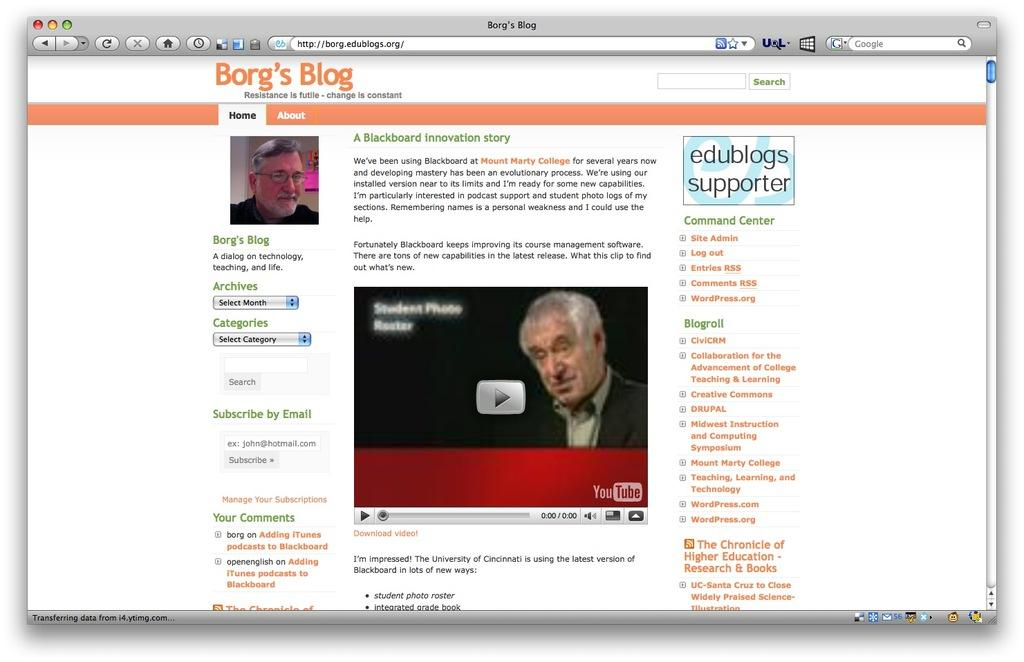What is the main subject of the image? The main subject of the image is a web page. What type of content can be seen on the web page? There are pictures of two men and an article visible on the web page. What flavor of food are the two men cooking in the image? There is no food or cooking depicted in the image; it features a web page with pictures of two men and an article. 